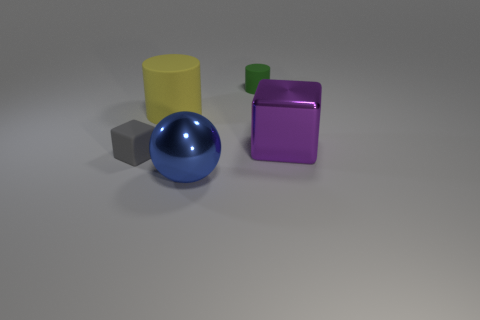Subtract all purple cubes. How many cubes are left? 1 Subtract 1 cubes. How many cubes are left? 1 Add 2 big brown metal things. How many big brown metal things exist? 2 Add 4 big green metallic balls. How many objects exist? 9 Subtract 0 red cubes. How many objects are left? 5 Subtract all spheres. How many objects are left? 4 Subtract all red cubes. Subtract all gray cylinders. How many cubes are left? 2 Subtract all cyan cylinders. How many gray blocks are left? 1 Subtract all small spheres. Subtract all big yellow cylinders. How many objects are left? 4 Add 3 big metal things. How many big metal things are left? 5 